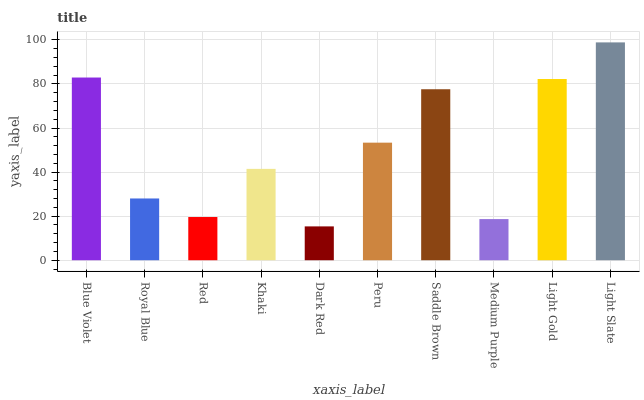Is Dark Red the minimum?
Answer yes or no. Yes. Is Light Slate the maximum?
Answer yes or no. Yes. Is Royal Blue the minimum?
Answer yes or no. No. Is Royal Blue the maximum?
Answer yes or no. No. Is Blue Violet greater than Royal Blue?
Answer yes or no. Yes. Is Royal Blue less than Blue Violet?
Answer yes or no. Yes. Is Royal Blue greater than Blue Violet?
Answer yes or no. No. Is Blue Violet less than Royal Blue?
Answer yes or no. No. Is Peru the high median?
Answer yes or no. Yes. Is Khaki the low median?
Answer yes or no. Yes. Is Light Gold the high median?
Answer yes or no. No. Is Dark Red the low median?
Answer yes or no. No. 